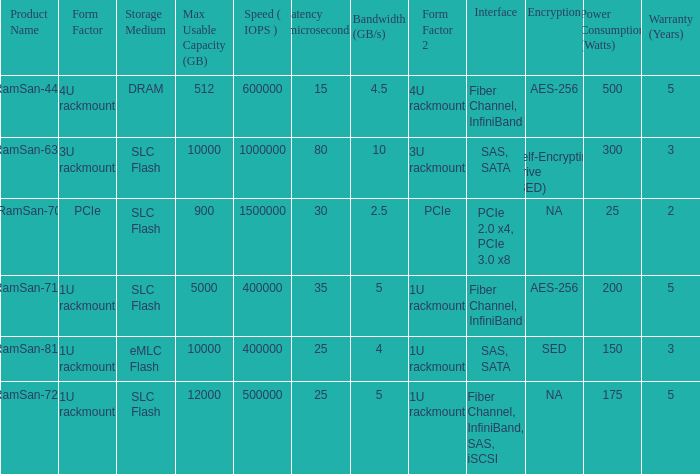List the number of ramsan-720 hard drives? 1.0. 